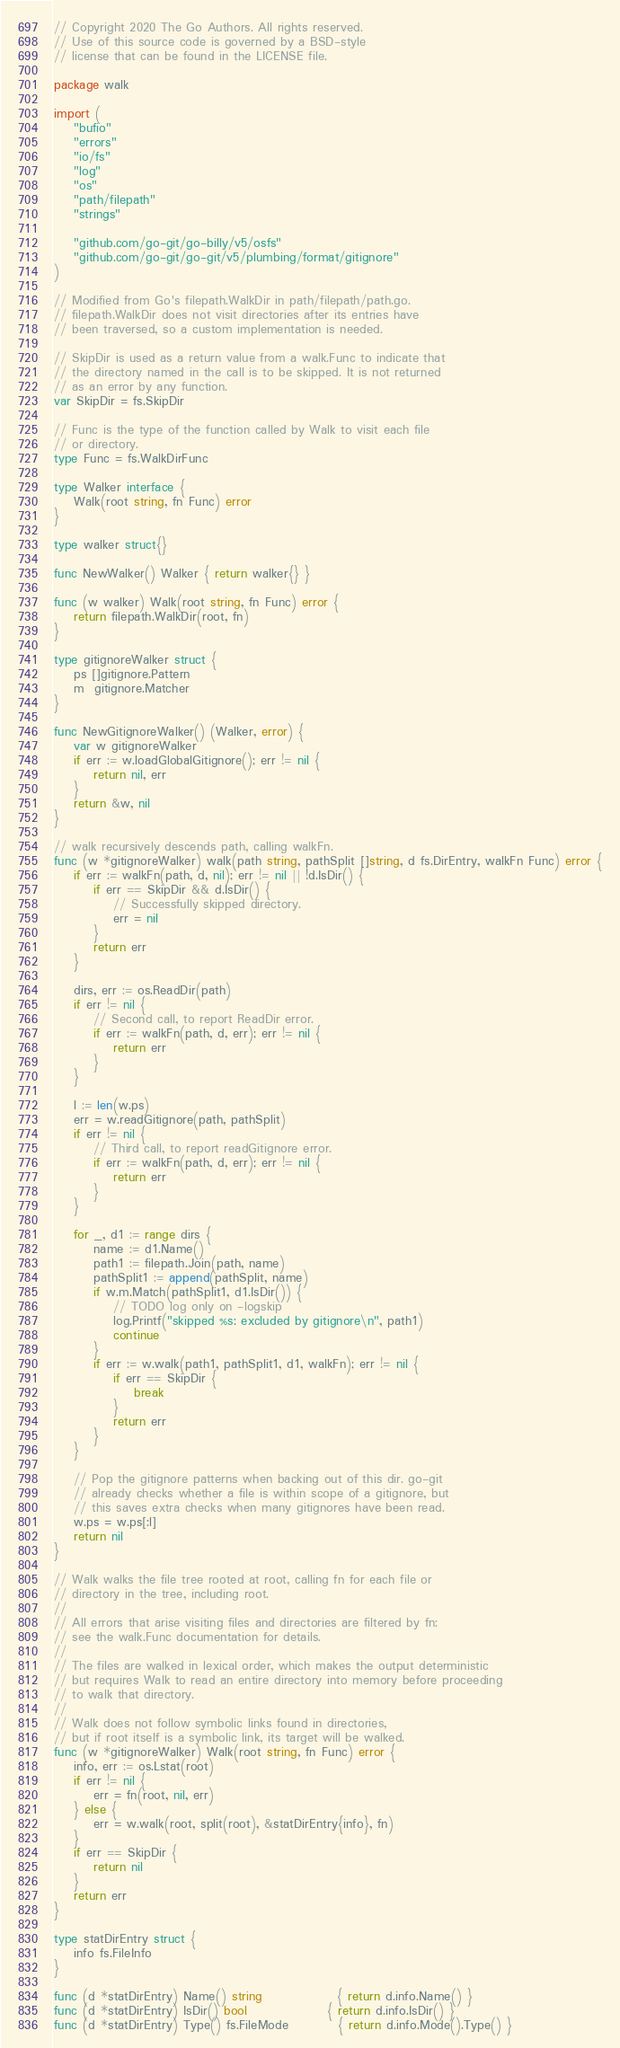Convert code to text. <code><loc_0><loc_0><loc_500><loc_500><_Go_>// Copyright 2020 The Go Authors. All rights reserved.
// Use of this source code is governed by a BSD-style
// license that can be found in the LICENSE file.

package walk

import (
	"bufio"
	"errors"
	"io/fs"
	"log"
	"os"
	"path/filepath"
	"strings"

	"github.com/go-git/go-billy/v5/osfs"
	"github.com/go-git/go-git/v5/plumbing/format/gitignore"
)

// Modified from Go's filepath.WalkDir in path/filepath/path.go.
// filepath.WalkDir does not visit directories after its entries have
// been traversed, so a custom implementation is needed.

// SkipDir is used as a return value from a walk.Func to indicate that
// the directory named in the call is to be skipped. It is not returned
// as an error by any function.
var SkipDir = fs.SkipDir

// Func is the type of the function called by Walk to visit each file
// or directory.
type Func = fs.WalkDirFunc

type Walker interface {
	Walk(root string, fn Func) error
}

type walker struct{}

func NewWalker() Walker { return walker{} }

func (w walker) Walk(root string, fn Func) error {
	return filepath.WalkDir(root, fn)
}

type gitignoreWalker struct {
	ps []gitignore.Pattern
	m  gitignore.Matcher
}

func NewGitignoreWalker() (Walker, error) {
	var w gitignoreWalker
	if err := w.loadGlobalGitignore(); err != nil {
		return nil, err
	}
	return &w, nil
}

// walk recursively descends path, calling walkFn.
func (w *gitignoreWalker) walk(path string, pathSplit []string, d fs.DirEntry, walkFn Func) error {
	if err := walkFn(path, d, nil); err != nil || !d.IsDir() {
		if err == SkipDir && d.IsDir() {
			// Successfully skipped directory.
			err = nil
		}
		return err
	}

	dirs, err := os.ReadDir(path)
	if err != nil {
		// Second call, to report ReadDir error.
		if err := walkFn(path, d, err); err != nil {
			return err
		}
	}

	l := len(w.ps)
	err = w.readGitignore(path, pathSplit)
	if err != nil {
		// Third call, to report readGitignore error.
		if err := walkFn(path, d, err); err != nil {
			return err
		}
	}

	for _, d1 := range dirs {
		name := d1.Name()
		path1 := filepath.Join(path, name)
		pathSplit1 := append(pathSplit, name)
		if w.m.Match(pathSplit1, d1.IsDir()) {
			// TODO log only on -logskip
			log.Printf("skipped %s: excluded by gitignore\n", path1)
			continue
		}
		if err := w.walk(path1, pathSplit1, d1, walkFn); err != nil {
			if err == SkipDir {
				break
			}
			return err
		}
	}

	// Pop the gitignore patterns when backing out of this dir. go-git
	// already checks whether a file is within scope of a gitignore, but
	// this saves extra checks when many gitignores have been read.
	w.ps = w.ps[:l]
	return nil
}

// Walk walks the file tree rooted at root, calling fn for each file or
// directory in the tree, including root.
//
// All errors that arise visiting files and directories are filtered by fn:
// see the walk.Func documentation for details.
//
// The files are walked in lexical order, which makes the output deterministic
// but requires Walk to read an entire directory into memory before proceeding
// to walk that directory.
//
// Walk does not follow symbolic links found in directories,
// but if root itself is a symbolic link, its target will be walked.
func (w *gitignoreWalker) Walk(root string, fn Func) error {
	info, err := os.Lstat(root)
	if err != nil {
		err = fn(root, nil, err)
	} else {
		err = w.walk(root, split(root), &statDirEntry{info}, fn)
	}
	if err == SkipDir {
		return nil
	}
	return err
}

type statDirEntry struct {
	info fs.FileInfo
}

func (d *statDirEntry) Name() string               { return d.info.Name() }
func (d *statDirEntry) IsDir() bool                { return d.info.IsDir() }
func (d *statDirEntry) Type() fs.FileMode          { return d.info.Mode().Type() }</code> 